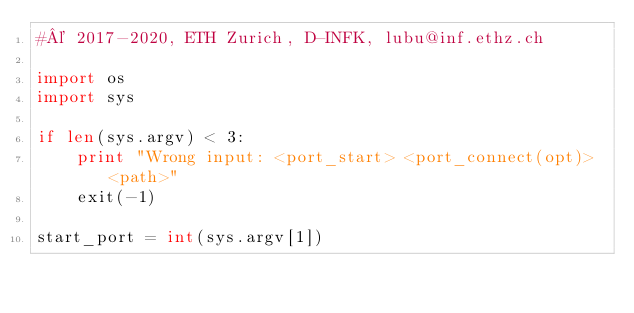<code> <loc_0><loc_0><loc_500><loc_500><_Python_>#© 2017-2020, ETH Zurich, D-INFK, lubu@inf.ethz.ch

import os
import sys

if len(sys.argv) < 3:
    print "Wrong input: <port_start> <port_connect(opt)> <path>"
    exit(-1)

start_port = int(sys.argv[1])</code> 